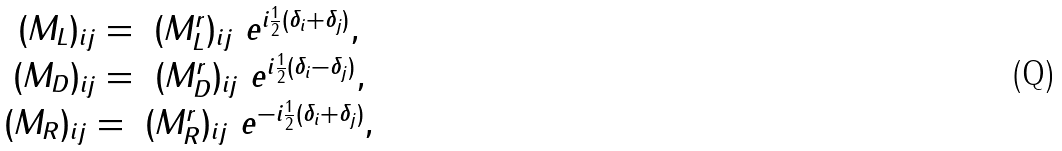<formula> <loc_0><loc_0><loc_500><loc_500>\begin{array} { c } { { ( M _ { L } ) _ { i j } = \ ( M _ { L } ^ { r } ) _ { i j } \ e ^ { i \frac { 1 } { 2 } ( \delta _ { i } + \delta _ { j } ) } , } } \\ { { ( M _ { D } ) _ { i j } = \ ( M _ { D } ^ { r } ) _ { i j } \ e ^ { i \frac { 1 } { 2 } ( \delta _ { i } - \delta _ { j } ) } , } } \\ { { ( M _ { R } ) _ { i j } = \ ( M _ { R } ^ { r } ) _ { i j } \ e ^ { - i \frac { 1 } { 2 } ( \delta _ { i } + \delta _ { j } ) } , } } \end{array}</formula> 